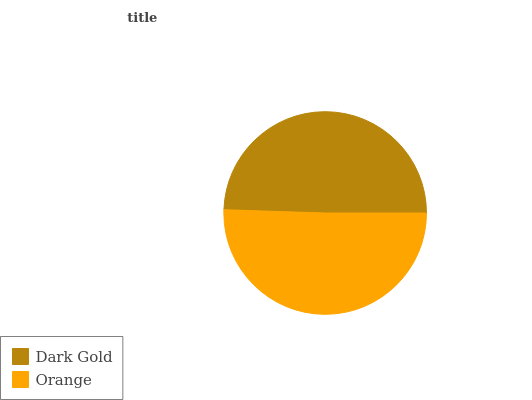Is Dark Gold the minimum?
Answer yes or no. Yes. Is Orange the maximum?
Answer yes or no. Yes. Is Orange the minimum?
Answer yes or no. No. Is Orange greater than Dark Gold?
Answer yes or no. Yes. Is Dark Gold less than Orange?
Answer yes or no. Yes. Is Dark Gold greater than Orange?
Answer yes or no. No. Is Orange less than Dark Gold?
Answer yes or no. No. Is Orange the high median?
Answer yes or no. Yes. Is Dark Gold the low median?
Answer yes or no. Yes. Is Dark Gold the high median?
Answer yes or no. No. Is Orange the low median?
Answer yes or no. No. 